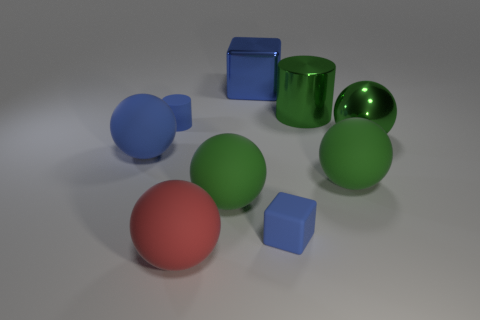Subtract all green metallic spheres. How many spheres are left? 4 Subtract 1 cylinders. How many cylinders are left? 1 Subtract all green spheres. How many spheres are left? 2 Subtract all cylinders. How many objects are left? 7 Subtract all red balls. Subtract all blue cubes. How many balls are left? 4 Subtract all cyan spheres. How many yellow blocks are left? 0 Subtract all green shiny cylinders. Subtract all balls. How many objects are left? 3 Add 6 large blue spheres. How many large blue spheres are left? 7 Add 9 small yellow matte cylinders. How many small yellow matte cylinders exist? 9 Subtract 0 purple cubes. How many objects are left? 9 